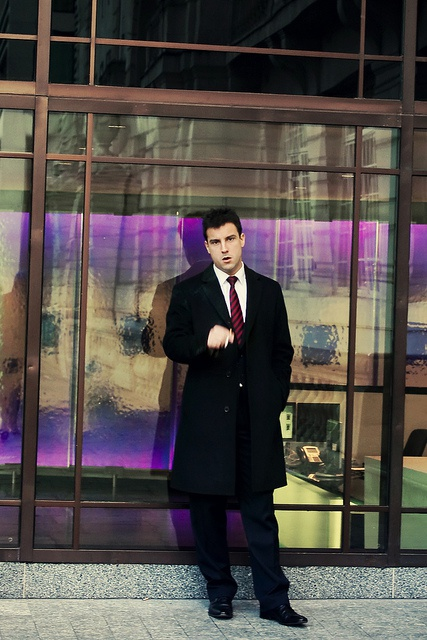Describe the objects in this image and their specific colors. I can see people in black, beige, and tan tones and tie in black, maroon, and brown tones in this image. 